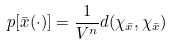Convert formula to latex. <formula><loc_0><loc_0><loc_500><loc_500>p [ \bar { x } ( \cdot ) ] = \frac { 1 } { V ^ { n } } d ( \chi _ { \bar { x } } , \chi _ { \bar { x } } )</formula> 